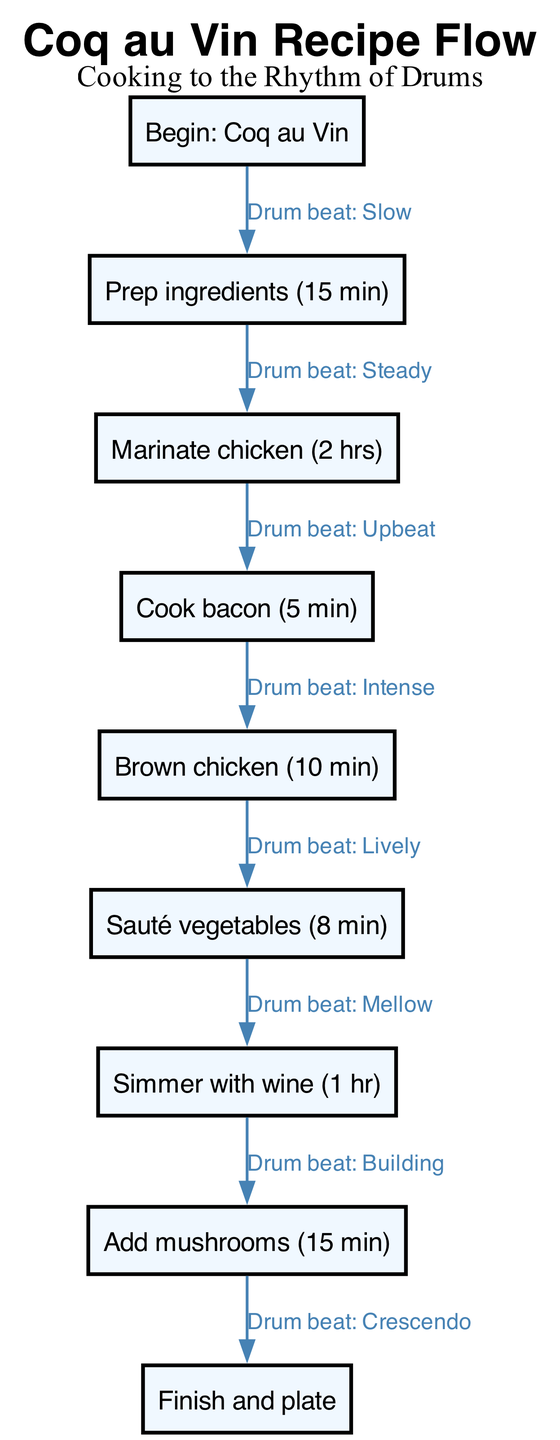What is the initial step in the recipe? The initial step is labeled as "Begin: Coq au Vin," which indicates the starting point of the recipe.
Answer: Begin: Coq au Vin How many minutes is allocated for ingredient preparation? The node for "Prep ingredients" specifies a time of 15 minutes, which is the allocated duration for this step.
Answer: 15 min What cooking method is used after marinating the chicken? The next step after the "Marinate chicken" node is "Cook bacon," which indicates the cooking method used at this stage.
Answer: Cook bacon What is the total time required for the chicken marination and bacon cooking steps combined? The time for marinating the chicken is 2 hours, and cooking bacon takes 5 minutes. Converting 2 hours to minutes gives 120 minutes, adding 5 minutes results in a total of 125 minutes.
Answer: 125 min List the steps in the process that involve sautéing. The only step that explicitly mentions sautéing is "Sauté vegetables." The previous step, "Brown chicken," also involves cooking, but only the “Sauté vegetables” specifically indicates sautéing.
Answer: Sauté vegetables What is the last action in the recipe flow chart? The final step in the flow chart is labeled "Finish and plate," which indicates the completion of the recipe process.
Answer: Finish and plate How many steps are there in total from the start to the finish node? Counting from "Begin: Coq au Vin" to "Finish and plate," there are a total of 8 steps: start, prep, marinade, bacon, chicken, vegetables, simmer, mushrooms, finish.
Answer: 8 What type of drum beat is associated with the simmering step? The diagram connects "Simmer with wine" to drumming labeled "Mellow," indicating the type of rhythm accompanying this cooking stage.
Answer: Mellow What step follows the addition of mushrooms in the recipe? The diagram shows that the step following "Add mushrooms" is "Finish and plate," indicating what comes next after this action.
Answer: Finish and plate 